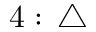<formula> <loc_0><loc_0><loc_500><loc_500>4 \colon \, \triangle</formula> 